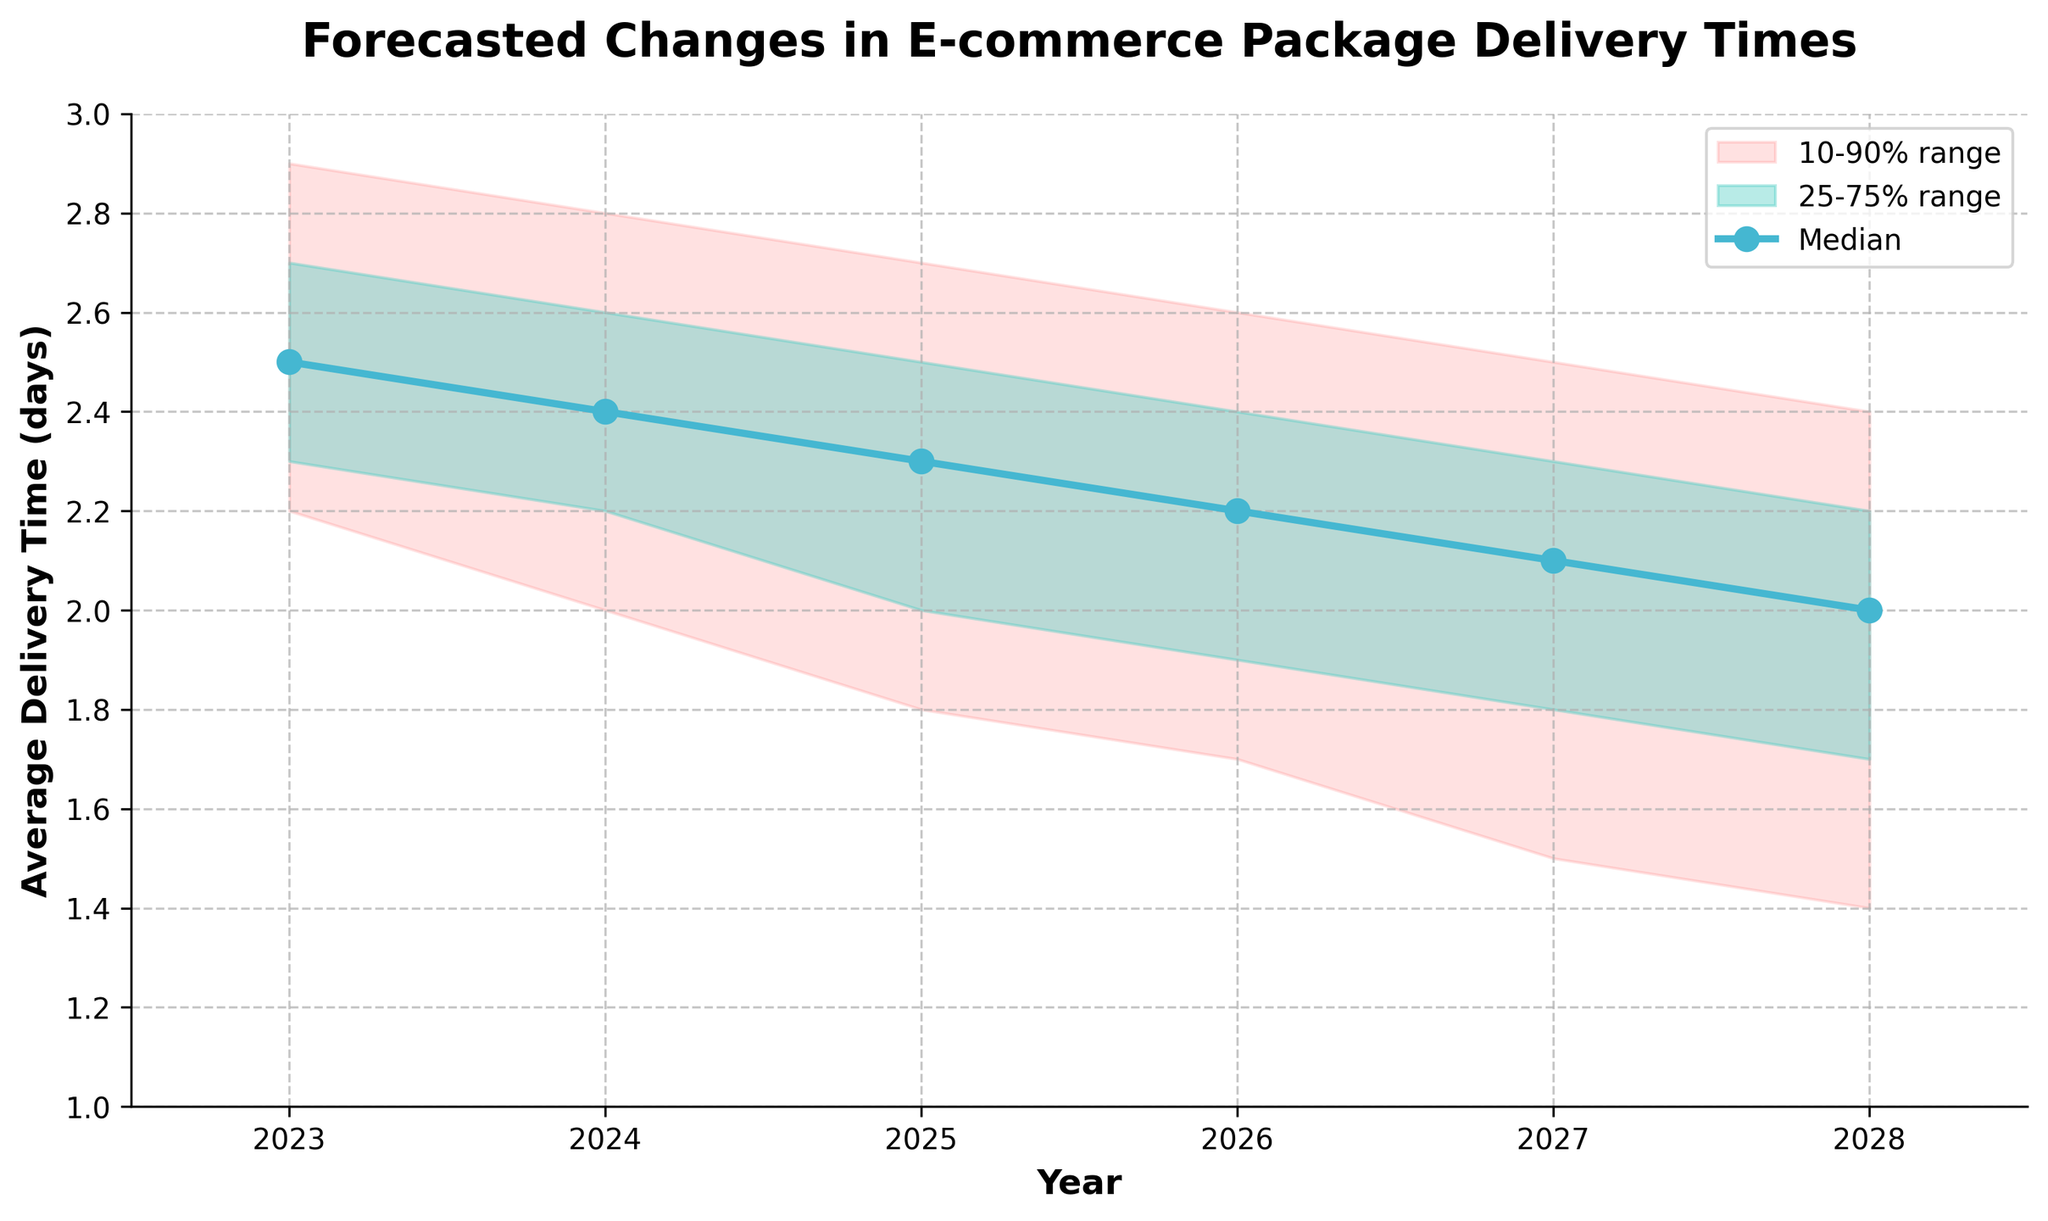What is the title of the figure? The title is located at the top of the figure, providing a brief overview of the content being presented. In this case, it reads "Forecasted Changes in E-commerce Package Delivery Times."
Answer: Forecasted Changes in E-commerce Package Delivery Times What is the median average delivery time in 2024? The median value can be found as the central line plot with circular markers for each year. For the year 2024, the median value is 2.4 days.
Answer: 2.4 days In which year does the median delivery time reach 2.1 days? To find this, look at the median line and find where it intersects with the value 2.1 on the y-axis. This occurs in the year 2027.
Answer: 2027 How much does the median delivery time decrease from 2023 to 2028? Subtract the median value in 2028 from the median value in 2023. From the graph, this is 2.5 days (2023) - 2.0 days (2028).
Answer: 0.5 days Between which years does the lower 10% value drop from above 2.0 to below 2.0? The lower 10% line represents the lower bound of the delivery times. This transition occurs between 2024 (lower 10% = 2.0) and 2025 (lower 10% = 1.8).
Answer: Between 2024 and 2025 What is the average value of the upper 90% forecasted range from 2025 to 2027? Sum the upper 90% values for the years 2025 to 2027 and divide by the number of years. (2.7 + 2.6 + 2.5) / 3 = 7.8 / 3
Answer: 2.6 Which year shows the narrowest range between the lower 10% and upper 90% values? Calculate the range for each year and find the smallest value. For each year: 
2023: (2.9 - 2.2) = 0.7 
2024: (2.8 - 2.0) = 0.8 
2025: (2.7 - 1.8) = 0.9 
2026: (2.6 - 1.7) = 0.9 
2027: (2.5 - 1.5) = 1.0 
2028: (2.4 - 1.4) = 1.0 
The narrowest range is in 2023.
Answer: 2023 What is the lower 25% value for the year 2026? This value is located within the shaded region, specifically at the lower edge of the more opaque middle band. For 2026, this value is 1.9 days.
Answer: 1.9 days How does the median delivery time trend from 2023 to 2028? Observing the median line from 2023 to 2028, it consistently trends downward, indicating a general decrease in delivery times.
Answer: Decreasing 